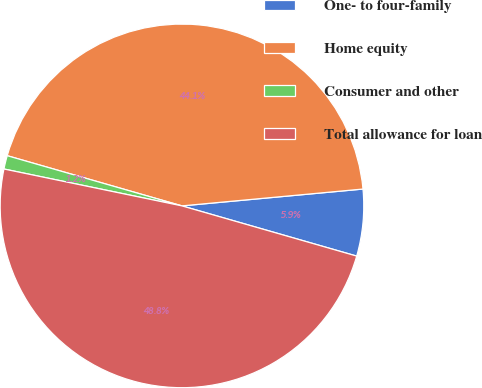<chart> <loc_0><loc_0><loc_500><loc_500><pie_chart><fcel>One- to four-family<fcel>Home equity<fcel>Consumer and other<fcel>Total allowance for loan<nl><fcel>5.93%<fcel>44.07%<fcel>1.2%<fcel>48.8%<nl></chart> 